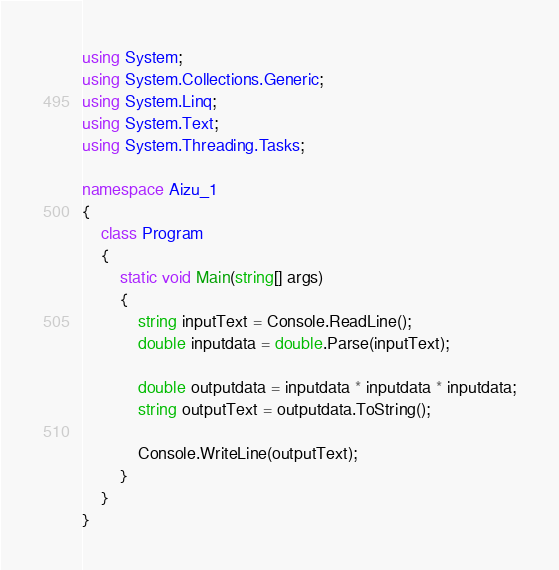Convert code to text. <code><loc_0><loc_0><loc_500><loc_500><_C#_>using System;
using System.Collections.Generic;
using System.Linq;
using System.Text;
using System.Threading.Tasks;

namespace Aizu_1
{
    class Program
    {
        static void Main(string[] args)
        {
            string inputText = Console.ReadLine();
            double inputdata = double.Parse(inputText);

            double outputdata = inputdata * inputdata * inputdata;
            string outputText = outputdata.ToString();

            Console.WriteLine(outputText);
        }
    }
}

</code> 